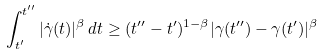<formula> <loc_0><loc_0><loc_500><loc_500>\int _ { t ^ { \prime } } ^ { t ^ { \prime \prime } } | \dot { \gamma } ( t ) | ^ { \beta } \, d t \geq ( t ^ { \prime \prime } - t ^ { \prime } ) ^ { 1 - \beta } | \gamma ( t ^ { \prime \prime } ) - \gamma ( t ^ { \prime } ) | ^ { \beta }</formula> 